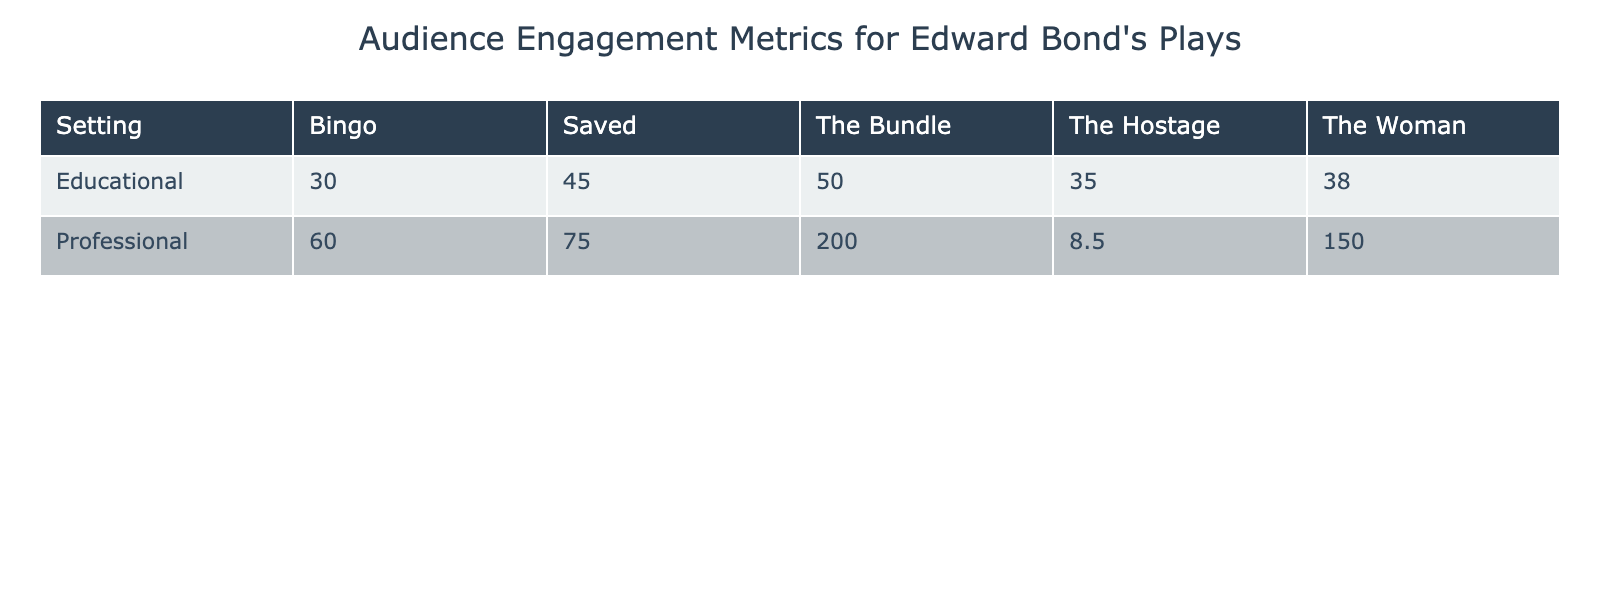What is the post-show discussion attendance for the play "Saved" in an educational setting? In the educational setting row for the play "Saved," the associated audience engagement metric is "Post-Show Discussion Attendance." By referring to the table, we find that the value listed is 45.
Answer: 45 What is the total value of ticket sales for "The Bundle" in professional settings? The table indicates that for the play "The Bundle" in the professional setting, the ticket sales number is 200. Since this is the only entry for "The Bundle" in a professional context, the total is 200.
Answer: 200 Is it true that the average audience rating for "The Woman" is greater than 8? For the play "The Woman" in the professional setting, the average audience rating is listed as 8.5. Since 8.5 is greater than 8, the statement is true.
Answer: Yes Which audience engagement metric had the highest value in educational settings? Looking through the educational setting metrics, we find "Classroom Analysis Participation" for "The Bundle" has the highest value of 50, compared to the other metrics which are lower. This indicates it is the most engaged metric in that context.
Answer: 50 What is the difference in social media mentions between "The Woman" in professional versus educational settings? In the professional setting, "The Woman" has 150 social media mentions. In the educational setting, there is no entry for "The Woman," so the value is 0. Thus, the difference is 150 - 0 = 150.
Answer: 150 How many plays have peer review ratings listed in educational settings? Referring to the table, "The Hostage" is the only play that has an audience engagement metric of "Peer Review Ratings" listed under educational settings. Thus, there is only 1 play.
Answer: 1 Which engagement metric for "Bingo" in educational settings has the lowest participation rate? In the educational setting for "Bingo," the audience engagement metric is "Workshop Involvement" with a participation rate of 30. This is the only metric provided for "Bingo," making it the lowest by default.
Answer: 30 What is the average of post-performance surveys for "Bingo" and "The Hostage" in professional settings? In the professional setting, "Bingo" has a value of 60 for post-performance surveys, while "The Hostage" does not have a corresponding survey value. So, only considering "Bingo," the average here calculates as 60/1 = 60.
Answer: 60 How many audience metrics listed are associated with educational settings? From the table, there are five distinct metrics listed under educational settings: Post-Show Discussion Attendance, Classroom Analysis Participation, Essay Submission Rates, Workshop Involvement, and Peer Review Ratings. Hence, there are a total of 5 metrics associated with educational settings.
Answer: 5 